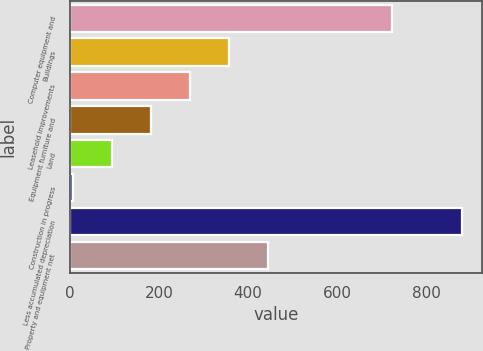<chart> <loc_0><loc_0><loc_500><loc_500><bar_chart><fcel>Computer equipment and<fcel>Buildings<fcel>Leasehold improvements<fcel>Equipment furniture and<fcel>Land<fcel>Construction in progress<fcel>Less accumulated depreciation<fcel>Property and equipment net<nl><fcel>723<fcel>356.6<fcel>269.2<fcel>181.8<fcel>94.4<fcel>7<fcel>881<fcel>444<nl></chart> 